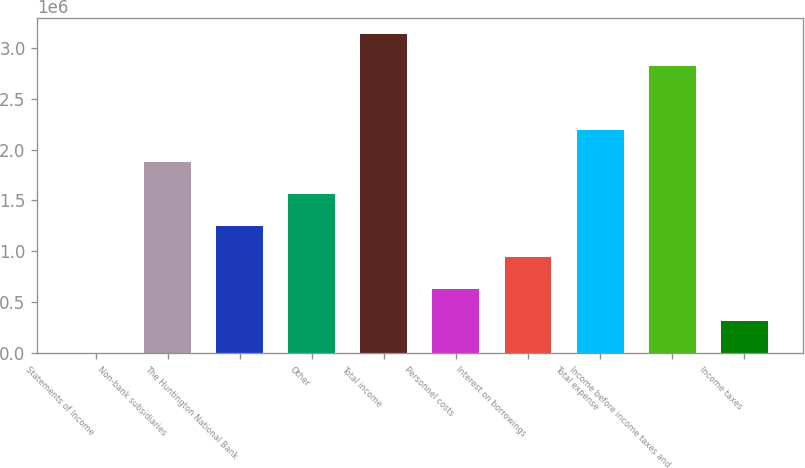<chart> <loc_0><loc_0><loc_500><loc_500><bar_chart><fcel>Statements of Income<fcel>Non-bank subsidiaries<fcel>The Huntington National Bank<fcel>Other<fcel>Total income<fcel>Personnel costs<fcel>Interest on borrowings<fcel>Total expense<fcel>Income before income taxes and<fcel>Income taxes<nl><fcel>2009<fcel>1.879e+06<fcel>1.25334e+06<fcel>1.56617e+06<fcel>3.13033e+06<fcel>627673<fcel>940505<fcel>2.19183e+06<fcel>2.8175e+06<fcel>314841<nl></chart> 